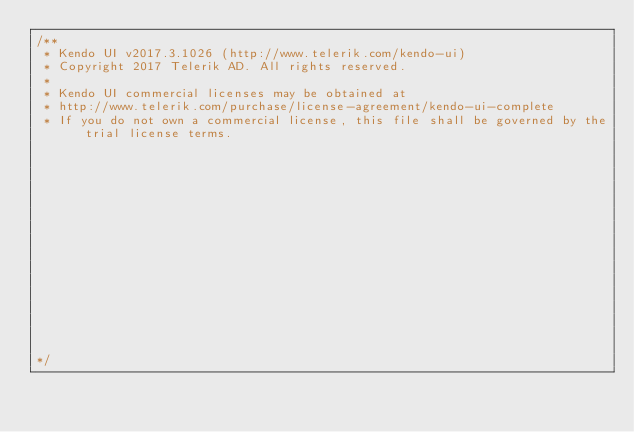Convert code to text. <code><loc_0><loc_0><loc_500><loc_500><_JavaScript_>/** 
 * Kendo UI v2017.3.1026 (http://www.telerik.com/kendo-ui)                                                                                                                                              
 * Copyright 2017 Telerik AD. All rights reserved.                                                                                                                                                      
 *                                                                                                                                                                                                      
 * Kendo UI commercial licenses may be obtained at                                                                                                                                                      
 * http://www.telerik.com/purchase/license-agreement/kendo-ui-complete                                                                                                                                  
 * If you do not own a commercial license, this file shall be governed by the trial license terms.                                                                                                      
                                                                                                                                                                                                       
                                                                                                                                                                                                       
                                                                                                                                                                                                       
                                                                                                                                                                                                       
                                                                                                                                                                                                       
                                                                                                                                                                                                       
                                                                                                                                                                                                       
                                                                                                                                                                                                       
                                                                                                                                                                                                       
                                                                                                                                                                                                       
                                                                                                                                                                                                       
                                                                                                                                                                                                       
                                                                                                                                                                                                       
                                                                                                                                                                                                       
                                                                                                                                                                                                       

*/</code> 